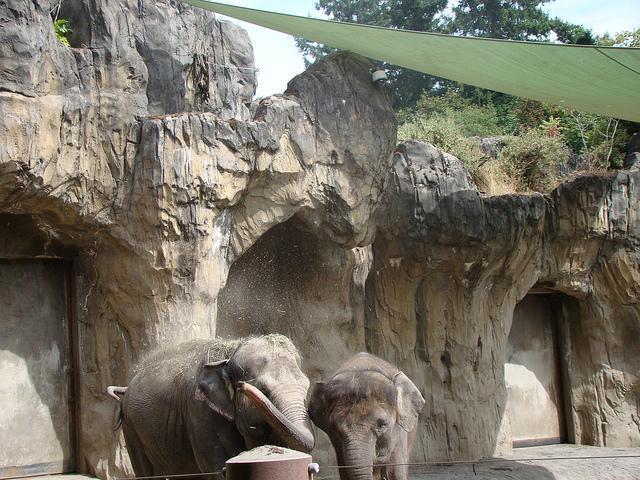How many elephants are there?
Give a very brief answer. 2. 